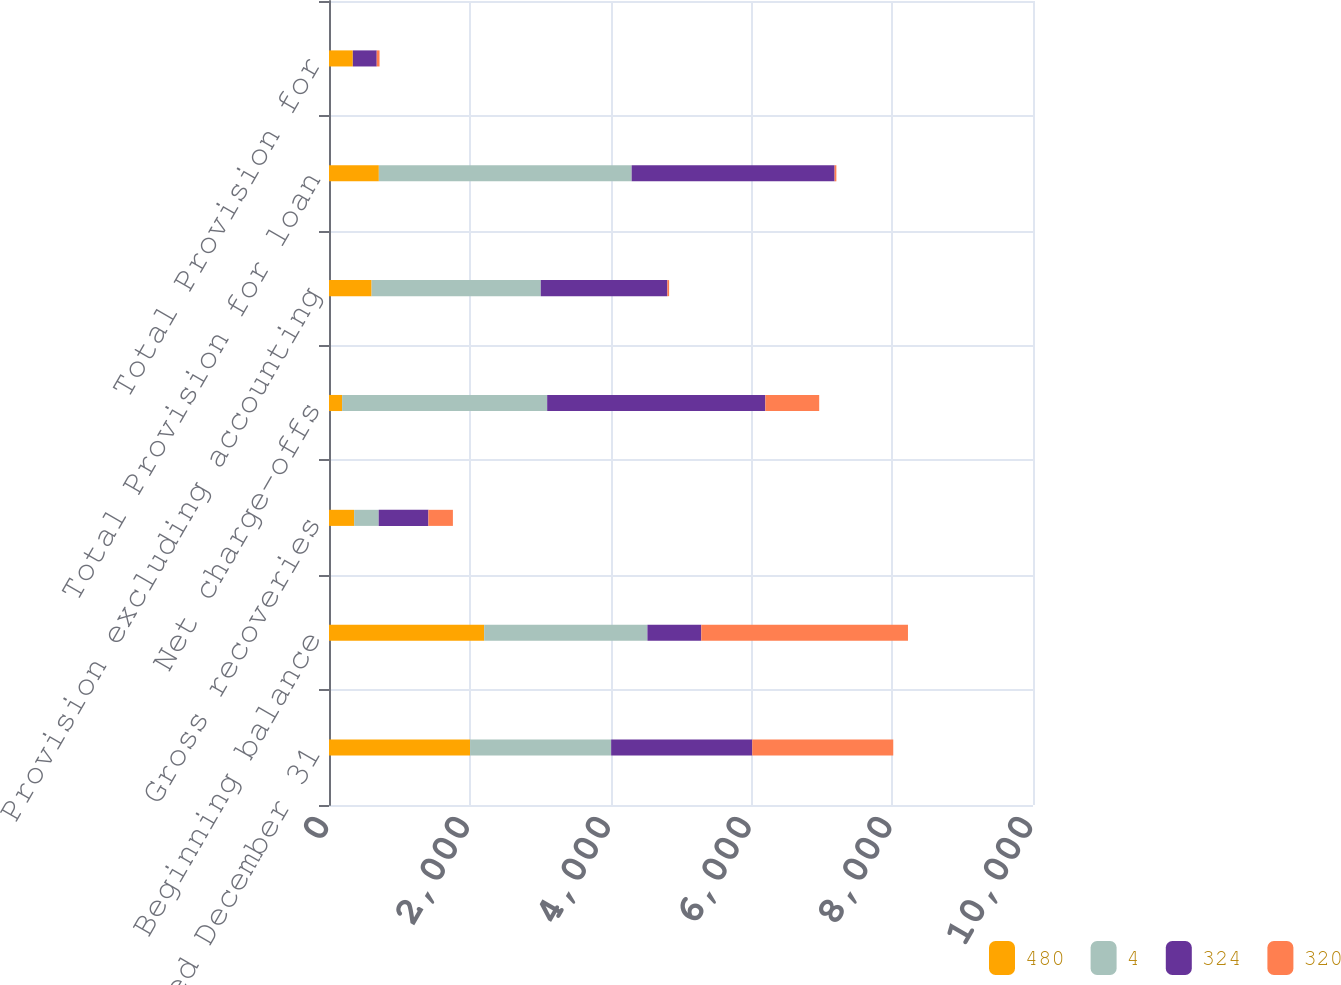Convert chart to OTSL. <chart><loc_0><loc_0><loc_500><loc_500><stacked_bar_chart><ecel><fcel>For the year ended December 31<fcel>Beginning balance<fcel>Gross recoveries<fcel>Net charge-offs<fcel>Provision excluding accounting<fcel>Total Provision for loan<fcel>Total Provision for<nl><fcel>480<fcel>2004<fcel>2204<fcel>357<fcel>186<fcel>605<fcel>708<fcel>338<nl><fcel>4<fcel>2004<fcel>2319<fcel>349<fcel>2913<fcel>2403<fcel>3591<fcel>1<nl><fcel>324<fcel>2004<fcel>765<fcel>706<fcel>3099<fcel>1798<fcel>2883<fcel>339<nl><fcel>320<fcel>2003<fcel>2936<fcel>348<fcel>765<fcel>25<fcel>25<fcel>40<nl></chart> 